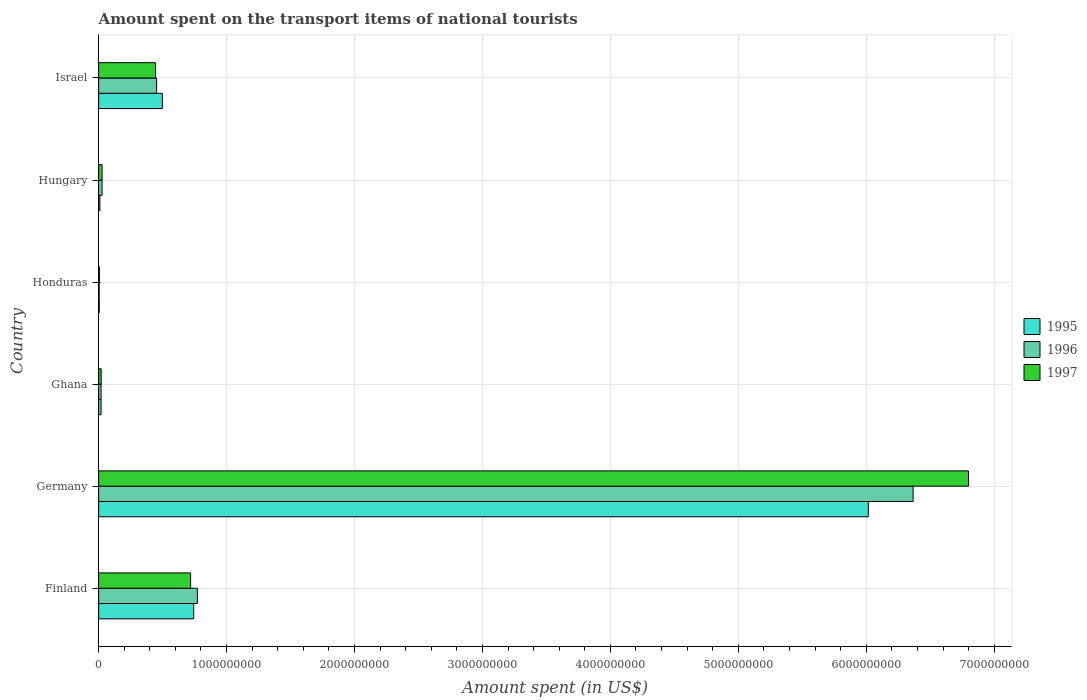How many different coloured bars are there?
Your response must be concise. 3. How many groups of bars are there?
Your answer should be very brief. 6. Are the number of bars on each tick of the Y-axis equal?
Offer a terse response. Yes. How many bars are there on the 1st tick from the top?
Keep it short and to the point. 3. What is the label of the 2nd group of bars from the top?
Provide a short and direct response. Hungary. In how many cases, is the number of bars for a given country not equal to the number of legend labels?
Offer a very short reply. 0. What is the amount spent on the transport items of national tourists in 1996 in Honduras?
Your answer should be very brief. 4.00e+06. Across all countries, what is the maximum amount spent on the transport items of national tourists in 1997?
Provide a short and direct response. 6.80e+09. Across all countries, what is the minimum amount spent on the transport items of national tourists in 1997?
Ensure brevity in your answer.  6.00e+06. In which country was the amount spent on the transport items of national tourists in 1995 minimum?
Your response must be concise. Honduras. What is the total amount spent on the transport items of national tourists in 1995 in the graph?
Your response must be concise. 7.29e+09. What is the difference between the amount spent on the transport items of national tourists in 1996 in Ghana and that in Hungary?
Provide a short and direct response. -8.00e+06. What is the difference between the amount spent on the transport items of national tourists in 1997 in Israel and the amount spent on the transport items of national tourists in 1996 in Finland?
Provide a short and direct response. -3.27e+08. What is the average amount spent on the transport items of national tourists in 1996 per country?
Keep it short and to the point. 1.27e+09. In how many countries, is the amount spent on the transport items of national tourists in 1995 greater than 5600000000 US$?
Offer a very short reply. 1. What is the ratio of the amount spent on the transport items of national tourists in 1995 in Honduras to that in Israel?
Offer a very short reply. 0.01. Is the difference between the amount spent on the transport items of national tourists in 1996 in Germany and Hungary greater than the difference between the amount spent on the transport items of national tourists in 1997 in Germany and Hungary?
Give a very brief answer. No. What is the difference between the highest and the second highest amount spent on the transport items of national tourists in 1995?
Ensure brevity in your answer.  5.27e+09. What is the difference between the highest and the lowest amount spent on the transport items of national tourists in 1995?
Offer a terse response. 6.01e+09. Is the sum of the amount spent on the transport items of national tourists in 1997 in Honduras and Hungary greater than the maximum amount spent on the transport items of national tourists in 1995 across all countries?
Make the answer very short. No. Is it the case that in every country, the sum of the amount spent on the transport items of national tourists in 1996 and amount spent on the transport items of national tourists in 1995 is greater than the amount spent on the transport items of national tourists in 1997?
Your answer should be compact. Yes. Are all the bars in the graph horizontal?
Keep it short and to the point. Yes. Are the values on the major ticks of X-axis written in scientific E-notation?
Provide a succinct answer. No. How many legend labels are there?
Offer a terse response. 3. How are the legend labels stacked?
Provide a succinct answer. Vertical. What is the title of the graph?
Provide a short and direct response. Amount spent on the transport items of national tourists. Does "2007" appear as one of the legend labels in the graph?
Ensure brevity in your answer.  No. What is the label or title of the X-axis?
Make the answer very short. Amount spent (in US$). What is the Amount spent (in US$) in 1995 in Finland?
Your response must be concise. 7.43e+08. What is the Amount spent (in US$) of 1996 in Finland?
Keep it short and to the point. 7.72e+08. What is the Amount spent (in US$) in 1997 in Finland?
Your response must be concise. 7.19e+08. What is the Amount spent (in US$) in 1995 in Germany?
Your response must be concise. 6.02e+09. What is the Amount spent (in US$) in 1996 in Germany?
Keep it short and to the point. 6.37e+09. What is the Amount spent (in US$) in 1997 in Germany?
Your response must be concise. 6.80e+09. What is the Amount spent (in US$) of 1995 in Ghana?
Your answer should be compact. 1.90e+07. What is the Amount spent (in US$) of 1996 in Ghana?
Provide a succinct answer. 1.90e+07. What is the Amount spent (in US$) of 1995 in Honduras?
Your answer should be very brief. 5.00e+06. What is the Amount spent (in US$) in 1997 in Honduras?
Your response must be concise. 6.00e+06. What is the Amount spent (in US$) in 1995 in Hungary?
Make the answer very short. 1.00e+07. What is the Amount spent (in US$) in 1996 in Hungary?
Provide a short and direct response. 2.70e+07. What is the Amount spent (in US$) of 1997 in Hungary?
Ensure brevity in your answer.  2.70e+07. What is the Amount spent (in US$) of 1995 in Israel?
Keep it short and to the point. 4.98e+08. What is the Amount spent (in US$) in 1996 in Israel?
Ensure brevity in your answer.  4.53e+08. What is the Amount spent (in US$) of 1997 in Israel?
Make the answer very short. 4.45e+08. Across all countries, what is the maximum Amount spent (in US$) in 1995?
Your answer should be compact. 6.02e+09. Across all countries, what is the maximum Amount spent (in US$) of 1996?
Provide a succinct answer. 6.37e+09. Across all countries, what is the maximum Amount spent (in US$) in 1997?
Offer a very short reply. 6.80e+09. Across all countries, what is the minimum Amount spent (in US$) in 1995?
Make the answer very short. 5.00e+06. Across all countries, what is the minimum Amount spent (in US$) of 1996?
Ensure brevity in your answer.  4.00e+06. What is the total Amount spent (in US$) of 1995 in the graph?
Provide a short and direct response. 7.29e+09. What is the total Amount spent (in US$) in 1996 in the graph?
Keep it short and to the point. 7.64e+09. What is the total Amount spent (in US$) of 1997 in the graph?
Make the answer very short. 8.02e+09. What is the difference between the Amount spent (in US$) in 1995 in Finland and that in Germany?
Ensure brevity in your answer.  -5.27e+09. What is the difference between the Amount spent (in US$) in 1996 in Finland and that in Germany?
Ensure brevity in your answer.  -5.59e+09. What is the difference between the Amount spent (in US$) in 1997 in Finland and that in Germany?
Offer a terse response. -6.08e+09. What is the difference between the Amount spent (in US$) of 1995 in Finland and that in Ghana?
Ensure brevity in your answer.  7.24e+08. What is the difference between the Amount spent (in US$) in 1996 in Finland and that in Ghana?
Your answer should be very brief. 7.53e+08. What is the difference between the Amount spent (in US$) of 1997 in Finland and that in Ghana?
Give a very brief answer. 6.99e+08. What is the difference between the Amount spent (in US$) of 1995 in Finland and that in Honduras?
Offer a terse response. 7.38e+08. What is the difference between the Amount spent (in US$) of 1996 in Finland and that in Honduras?
Keep it short and to the point. 7.68e+08. What is the difference between the Amount spent (in US$) of 1997 in Finland and that in Honduras?
Offer a very short reply. 7.13e+08. What is the difference between the Amount spent (in US$) of 1995 in Finland and that in Hungary?
Make the answer very short. 7.33e+08. What is the difference between the Amount spent (in US$) of 1996 in Finland and that in Hungary?
Offer a very short reply. 7.45e+08. What is the difference between the Amount spent (in US$) of 1997 in Finland and that in Hungary?
Provide a short and direct response. 6.92e+08. What is the difference between the Amount spent (in US$) of 1995 in Finland and that in Israel?
Ensure brevity in your answer.  2.45e+08. What is the difference between the Amount spent (in US$) in 1996 in Finland and that in Israel?
Keep it short and to the point. 3.19e+08. What is the difference between the Amount spent (in US$) of 1997 in Finland and that in Israel?
Ensure brevity in your answer.  2.74e+08. What is the difference between the Amount spent (in US$) in 1995 in Germany and that in Ghana?
Ensure brevity in your answer.  6.00e+09. What is the difference between the Amount spent (in US$) of 1996 in Germany and that in Ghana?
Offer a very short reply. 6.35e+09. What is the difference between the Amount spent (in US$) in 1997 in Germany and that in Ghana?
Your answer should be very brief. 6.78e+09. What is the difference between the Amount spent (in US$) of 1995 in Germany and that in Honduras?
Provide a succinct answer. 6.01e+09. What is the difference between the Amount spent (in US$) in 1996 in Germany and that in Honduras?
Keep it short and to the point. 6.36e+09. What is the difference between the Amount spent (in US$) of 1997 in Germany and that in Honduras?
Your response must be concise. 6.79e+09. What is the difference between the Amount spent (in US$) in 1995 in Germany and that in Hungary?
Provide a short and direct response. 6.01e+09. What is the difference between the Amount spent (in US$) in 1996 in Germany and that in Hungary?
Make the answer very short. 6.34e+09. What is the difference between the Amount spent (in US$) in 1997 in Germany and that in Hungary?
Provide a succinct answer. 6.77e+09. What is the difference between the Amount spent (in US$) of 1995 in Germany and that in Israel?
Give a very brief answer. 5.52e+09. What is the difference between the Amount spent (in US$) of 1996 in Germany and that in Israel?
Offer a very short reply. 5.91e+09. What is the difference between the Amount spent (in US$) of 1997 in Germany and that in Israel?
Ensure brevity in your answer.  6.35e+09. What is the difference between the Amount spent (in US$) in 1995 in Ghana and that in Honduras?
Offer a very short reply. 1.40e+07. What is the difference between the Amount spent (in US$) in 1996 in Ghana and that in Honduras?
Your answer should be compact. 1.50e+07. What is the difference between the Amount spent (in US$) in 1997 in Ghana and that in Honduras?
Your answer should be compact. 1.40e+07. What is the difference between the Amount spent (in US$) in 1995 in Ghana and that in Hungary?
Provide a succinct answer. 9.00e+06. What is the difference between the Amount spent (in US$) of 1996 in Ghana and that in Hungary?
Your response must be concise. -8.00e+06. What is the difference between the Amount spent (in US$) in 1997 in Ghana and that in Hungary?
Your response must be concise. -7.00e+06. What is the difference between the Amount spent (in US$) of 1995 in Ghana and that in Israel?
Make the answer very short. -4.79e+08. What is the difference between the Amount spent (in US$) of 1996 in Ghana and that in Israel?
Make the answer very short. -4.34e+08. What is the difference between the Amount spent (in US$) of 1997 in Ghana and that in Israel?
Offer a terse response. -4.25e+08. What is the difference between the Amount spent (in US$) of 1995 in Honduras and that in Hungary?
Ensure brevity in your answer.  -5.00e+06. What is the difference between the Amount spent (in US$) of 1996 in Honduras and that in Hungary?
Provide a short and direct response. -2.30e+07. What is the difference between the Amount spent (in US$) of 1997 in Honduras and that in Hungary?
Ensure brevity in your answer.  -2.10e+07. What is the difference between the Amount spent (in US$) of 1995 in Honduras and that in Israel?
Provide a succinct answer. -4.93e+08. What is the difference between the Amount spent (in US$) of 1996 in Honduras and that in Israel?
Keep it short and to the point. -4.49e+08. What is the difference between the Amount spent (in US$) in 1997 in Honduras and that in Israel?
Offer a terse response. -4.39e+08. What is the difference between the Amount spent (in US$) in 1995 in Hungary and that in Israel?
Your answer should be very brief. -4.88e+08. What is the difference between the Amount spent (in US$) in 1996 in Hungary and that in Israel?
Provide a short and direct response. -4.26e+08. What is the difference between the Amount spent (in US$) of 1997 in Hungary and that in Israel?
Your response must be concise. -4.18e+08. What is the difference between the Amount spent (in US$) of 1995 in Finland and the Amount spent (in US$) of 1996 in Germany?
Make the answer very short. -5.62e+09. What is the difference between the Amount spent (in US$) in 1995 in Finland and the Amount spent (in US$) in 1997 in Germany?
Your answer should be very brief. -6.06e+09. What is the difference between the Amount spent (in US$) in 1996 in Finland and the Amount spent (in US$) in 1997 in Germany?
Ensure brevity in your answer.  -6.03e+09. What is the difference between the Amount spent (in US$) in 1995 in Finland and the Amount spent (in US$) in 1996 in Ghana?
Your response must be concise. 7.24e+08. What is the difference between the Amount spent (in US$) in 1995 in Finland and the Amount spent (in US$) in 1997 in Ghana?
Offer a terse response. 7.23e+08. What is the difference between the Amount spent (in US$) in 1996 in Finland and the Amount spent (in US$) in 1997 in Ghana?
Your response must be concise. 7.52e+08. What is the difference between the Amount spent (in US$) of 1995 in Finland and the Amount spent (in US$) of 1996 in Honduras?
Your answer should be very brief. 7.39e+08. What is the difference between the Amount spent (in US$) of 1995 in Finland and the Amount spent (in US$) of 1997 in Honduras?
Your response must be concise. 7.37e+08. What is the difference between the Amount spent (in US$) in 1996 in Finland and the Amount spent (in US$) in 1997 in Honduras?
Keep it short and to the point. 7.66e+08. What is the difference between the Amount spent (in US$) in 1995 in Finland and the Amount spent (in US$) in 1996 in Hungary?
Offer a terse response. 7.16e+08. What is the difference between the Amount spent (in US$) in 1995 in Finland and the Amount spent (in US$) in 1997 in Hungary?
Make the answer very short. 7.16e+08. What is the difference between the Amount spent (in US$) in 1996 in Finland and the Amount spent (in US$) in 1997 in Hungary?
Your answer should be very brief. 7.45e+08. What is the difference between the Amount spent (in US$) of 1995 in Finland and the Amount spent (in US$) of 1996 in Israel?
Your answer should be compact. 2.90e+08. What is the difference between the Amount spent (in US$) in 1995 in Finland and the Amount spent (in US$) in 1997 in Israel?
Offer a very short reply. 2.98e+08. What is the difference between the Amount spent (in US$) of 1996 in Finland and the Amount spent (in US$) of 1997 in Israel?
Offer a very short reply. 3.27e+08. What is the difference between the Amount spent (in US$) in 1995 in Germany and the Amount spent (in US$) in 1996 in Ghana?
Your answer should be very brief. 6.00e+09. What is the difference between the Amount spent (in US$) in 1995 in Germany and the Amount spent (in US$) in 1997 in Ghana?
Provide a succinct answer. 6.00e+09. What is the difference between the Amount spent (in US$) of 1996 in Germany and the Amount spent (in US$) of 1997 in Ghana?
Provide a short and direct response. 6.35e+09. What is the difference between the Amount spent (in US$) of 1995 in Germany and the Amount spent (in US$) of 1996 in Honduras?
Your answer should be compact. 6.01e+09. What is the difference between the Amount spent (in US$) of 1995 in Germany and the Amount spent (in US$) of 1997 in Honduras?
Make the answer very short. 6.01e+09. What is the difference between the Amount spent (in US$) of 1996 in Germany and the Amount spent (in US$) of 1997 in Honduras?
Keep it short and to the point. 6.36e+09. What is the difference between the Amount spent (in US$) in 1995 in Germany and the Amount spent (in US$) in 1996 in Hungary?
Keep it short and to the point. 5.99e+09. What is the difference between the Amount spent (in US$) in 1995 in Germany and the Amount spent (in US$) in 1997 in Hungary?
Your answer should be very brief. 5.99e+09. What is the difference between the Amount spent (in US$) in 1996 in Germany and the Amount spent (in US$) in 1997 in Hungary?
Ensure brevity in your answer.  6.34e+09. What is the difference between the Amount spent (in US$) in 1995 in Germany and the Amount spent (in US$) in 1996 in Israel?
Provide a succinct answer. 5.56e+09. What is the difference between the Amount spent (in US$) of 1995 in Germany and the Amount spent (in US$) of 1997 in Israel?
Make the answer very short. 5.57e+09. What is the difference between the Amount spent (in US$) in 1996 in Germany and the Amount spent (in US$) in 1997 in Israel?
Ensure brevity in your answer.  5.92e+09. What is the difference between the Amount spent (in US$) of 1995 in Ghana and the Amount spent (in US$) of 1996 in Honduras?
Your answer should be compact. 1.50e+07. What is the difference between the Amount spent (in US$) in 1995 in Ghana and the Amount spent (in US$) in 1997 in Honduras?
Your answer should be compact. 1.30e+07. What is the difference between the Amount spent (in US$) of 1996 in Ghana and the Amount spent (in US$) of 1997 in Honduras?
Make the answer very short. 1.30e+07. What is the difference between the Amount spent (in US$) in 1995 in Ghana and the Amount spent (in US$) in 1996 in Hungary?
Provide a succinct answer. -8.00e+06. What is the difference between the Amount spent (in US$) in 1995 in Ghana and the Amount spent (in US$) in 1997 in Hungary?
Offer a terse response. -8.00e+06. What is the difference between the Amount spent (in US$) of 1996 in Ghana and the Amount spent (in US$) of 1997 in Hungary?
Your response must be concise. -8.00e+06. What is the difference between the Amount spent (in US$) of 1995 in Ghana and the Amount spent (in US$) of 1996 in Israel?
Offer a very short reply. -4.34e+08. What is the difference between the Amount spent (in US$) of 1995 in Ghana and the Amount spent (in US$) of 1997 in Israel?
Provide a succinct answer. -4.26e+08. What is the difference between the Amount spent (in US$) in 1996 in Ghana and the Amount spent (in US$) in 1997 in Israel?
Make the answer very short. -4.26e+08. What is the difference between the Amount spent (in US$) of 1995 in Honduras and the Amount spent (in US$) of 1996 in Hungary?
Make the answer very short. -2.20e+07. What is the difference between the Amount spent (in US$) of 1995 in Honduras and the Amount spent (in US$) of 1997 in Hungary?
Give a very brief answer. -2.20e+07. What is the difference between the Amount spent (in US$) of 1996 in Honduras and the Amount spent (in US$) of 1997 in Hungary?
Provide a succinct answer. -2.30e+07. What is the difference between the Amount spent (in US$) in 1995 in Honduras and the Amount spent (in US$) in 1996 in Israel?
Offer a very short reply. -4.48e+08. What is the difference between the Amount spent (in US$) of 1995 in Honduras and the Amount spent (in US$) of 1997 in Israel?
Your answer should be very brief. -4.40e+08. What is the difference between the Amount spent (in US$) in 1996 in Honduras and the Amount spent (in US$) in 1997 in Israel?
Ensure brevity in your answer.  -4.41e+08. What is the difference between the Amount spent (in US$) in 1995 in Hungary and the Amount spent (in US$) in 1996 in Israel?
Your response must be concise. -4.43e+08. What is the difference between the Amount spent (in US$) of 1995 in Hungary and the Amount spent (in US$) of 1997 in Israel?
Your answer should be compact. -4.35e+08. What is the difference between the Amount spent (in US$) of 1996 in Hungary and the Amount spent (in US$) of 1997 in Israel?
Offer a terse response. -4.18e+08. What is the average Amount spent (in US$) of 1995 per country?
Your answer should be compact. 1.22e+09. What is the average Amount spent (in US$) of 1996 per country?
Provide a short and direct response. 1.27e+09. What is the average Amount spent (in US$) in 1997 per country?
Your answer should be compact. 1.34e+09. What is the difference between the Amount spent (in US$) of 1995 and Amount spent (in US$) of 1996 in Finland?
Keep it short and to the point. -2.90e+07. What is the difference between the Amount spent (in US$) in 1995 and Amount spent (in US$) in 1997 in Finland?
Your response must be concise. 2.40e+07. What is the difference between the Amount spent (in US$) of 1996 and Amount spent (in US$) of 1997 in Finland?
Give a very brief answer. 5.30e+07. What is the difference between the Amount spent (in US$) of 1995 and Amount spent (in US$) of 1996 in Germany?
Your answer should be compact. -3.50e+08. What is the difference between the Amount spent (in US$) in 1995 and Amount spent (in US$) in 1997 in Germany?
Provide a succinct answer. -7.83e+08. What is the difference between the Amount spent (in US$) of 1996 and Amount spent (in US$) of 1997 in Germany?
Make the answer very short. -4.33e+08. What is the difference between the Amount spent (in US$) in 1995 and Amount spent (in US$) in 1997 in Ghana?
Offer a very short reply. -1.00e+06. What is the difference between the Amount spent (in US$) in 1995 and Amount spent (in US$) in 1996 in Hungary?
Provide a short and direct response. -1.70e+07. What is the difference between the Amount spent (in US$) in 1995 and Amount spent (in US$) in 1997 in Hungary?
Offer a terse response. -1.70e+07. What is the difference between the Amount spent (in US$) of 1995 and Amount spent (in US$) of 1996 in Israel?
Your answer should be compact. 4.50e+07. What is the difference between the Amount spent (in US$) in 1995 and Amount spent (in US$) in 1997 in Israel?
Keep it short and to the point. 5.30e+07. What is the ratio of the Amount spent (in US$) of 1995 in Finland to that in Germany?
Offer a terse response. 0.12. What is the ratio of the Amount spent (in US$) of 1996 in Finland to that in Germany?
Offer a terse response. 0.12. What is the ratio of the Amount spent (in US$) in 1997 in Finland to that in Germany?
Keep it short and to the point. 0.11. What is the ratio of the Amount spent (in US$) in 1995 in Finland to that in Ghana?
Provide a short and direct response. 39.11. What is the ratio of the Amount spent (in US$) of 1996 in Finland to that in Ghana?
Your answer should be very brief. 40.63. What is the ratio of the Amount spent (in US$) of 1997 in Finland to that in Ghana?
Your response must be concise. 35.95. What is the ratio of the Amount spent (in US$) in 1995 in Finland to that in Honduras?
Offer a very short reply. 148.6. What is the ratio of the Amount spent (in US$) in 1996 in Finland to that in Honduras?
Your response must be concise. 193. What is the ratio of the Amount spent (in US$) of 1997 in Finland to that in Honduras?
Your response must be concise. 119.83. What is the ratio of the Amount spent (in US$) in 1995 in Finland to that in Hungary?
Offer a terse response. 74.3. What is the ratio of the Amount spent (in US$) of 1996 in Finland to that in Hungary?
Provide a short and direct response. 28.59. What is the ratio of the Amount spent (in US$) of 1997 in Finland to that in Hungary?
Your answer should be compact. 26.63. What is the ratio of the Amount spent (in US$) in 1995 in Finland to that in Israel?
Your response must be concise. 1.49. What is the ratio of the Amount spent (in US$) in 1996 in Finland to that in Israel?
Make the answer very short. 1.7. What is the ratio of the Amount spent (in US$) of 1997 in Finland to that in Israel?
Your response must be concise. 1.62. What is the ratio of the Amount spent (in US$) of 1995 in Germany to that in Ghana?
Offer a terse response. 316.63. What is the ratio of the Amount spent (in US$) of 1996 in Germany to that in Ghana?
Provide a short and direct response. 335.05. What is the ratio of the Amount spent (in US$) of 1997 in Germany to that in Ghana?
Ensure brevity in your answer.  339.95. What is the ratio of the Amount spent (in US$) in 1995 in Germany to that in Honduras?
Ensure brevity in your answer.  1203.2. What is the ratio of the Amount spent (in US$) in 1996 in Germany to that in Honduras?
Make the answer very short. 1591.5. What is the ratio of the Amount spent (in US$) of 1997 in Germany to that in Honduras?
Offer a terse response. 1133.17. What is the ratio of the Amount spent (in US$) of 1995 in Germany to that in Hungary?
Offer a very short reply. 601.6. What is the ratio of the Amount spent (in US$) in 1996 in Germany to that in Hungary?
Your response must be concise. 235.78. What is the ratio of the Amount spent (in US$) of 1997 in Germany to that in Hungary?
Offer a very short reply. 251.81. What is the ratio of the Amount spent (in US$) of 1995 in Germany to that in Israel?
Provide a succinct answer. 12.08. What is the ratio of the Amount spent (in US$) in 1996 in Germany to that in Israel?
Offer a terse response. 14.05. What is the ratio of the Amount spent (in US$) in 1997 in Germany to that in Israel?
Give a very brief answer. 15.28. What is the ratio of the Amount spent (in US$) of 1995 in Ghana to that in Honduras?
Give a very brief answer. 3.8. What is the ratio of the Amount spent (in US$) in 1996 in Ghana to that in Honduras?
Your answer should be very brief. 4.75. What is the ratio of the Amount spent (in US$) in 1995 in Ghana to that in Hungary?
Ensure brevity in your answer.  1.9. What is the ratio of the Amount spent (in US$) in 1996 in Ghana to that in Hungary?
Your response must be concise. 0.7. What is the ratio of the Amount spent (in US$) of 1997 in Ghana to that in Hungary?
Your answer should be very brief. 0.74. What is the ratio of the Amount spent (in US$) in 1995 in Ghana to that in Israel?
Your answer should be compact. 0.04. What is the ratio of the Amount spent (in US$) in 1996 in Ghana to that in Israel?
Your response must be concise. 0.04. What is the ratio of the Amount spent (in US$) of 1997 in Ghana to that in Israel?
Offer a very short reply. 0.04. What is the ratio of the Amount spent (in US$) of 1996 in Honduras to that in Hungary?
Keep it short and to the point. 0.15. What is the ratio of the Amount spent (in US$) of 1997 in Honduras to that in Hungary?
Offer a terse response. 0.22. What is the ratio of the Amount spent (in US$) in 1995 in Honduras to that in Israel?
Ensure brevity in your answer.  0.01. What is the ratio of the Amount spent (in US$) of 1996 in Honduras to that in Israel?
Offer a terse response. 0.01. What is the ratio of the Amount spent (in US$) of 1997 in Honduras to that in Israel?
Make the answer very short. 0.01. What is the ratio of the Amount spent (in US$) of 1995 in Hungary to that in Israel?
Give a very brief answer. 0.02. What is the ratio of the Amount spent (in US$) of 1996 in Hungary to that in Israel?
Your answer should be compact. 0.06. What is the ratio of the Amount spent (in US$) of 1997 in Hungary to that in Israel?
Provide a succinct answer. 0.06. What is the difference between the highest and the second highest Amount spent (in US$) of 1995?
Make the answer very short. 5.27e+09. What is the difference between the highest and the second highest Amount spent (in US$) in 1996?
Offer a very short reply. 5.59e+09. What is the difference between the highest and the second highest Amount spent (in US$) in 1997?
Your answer should be compact. 6.08e+09. What is the difference between the highest and the lowest Amount spent (in US$) of 1995?
Give a very brief answer. 6.01e+09. What is the difference between the highest and the lowest Amount spent (in US$) of 1996?
Your response must be concise. 6.36e+09. What is the difference between the highest and the lowest Amount spent (in US$) of 1997?
Provide a succinct answer. 6.79e+09. 